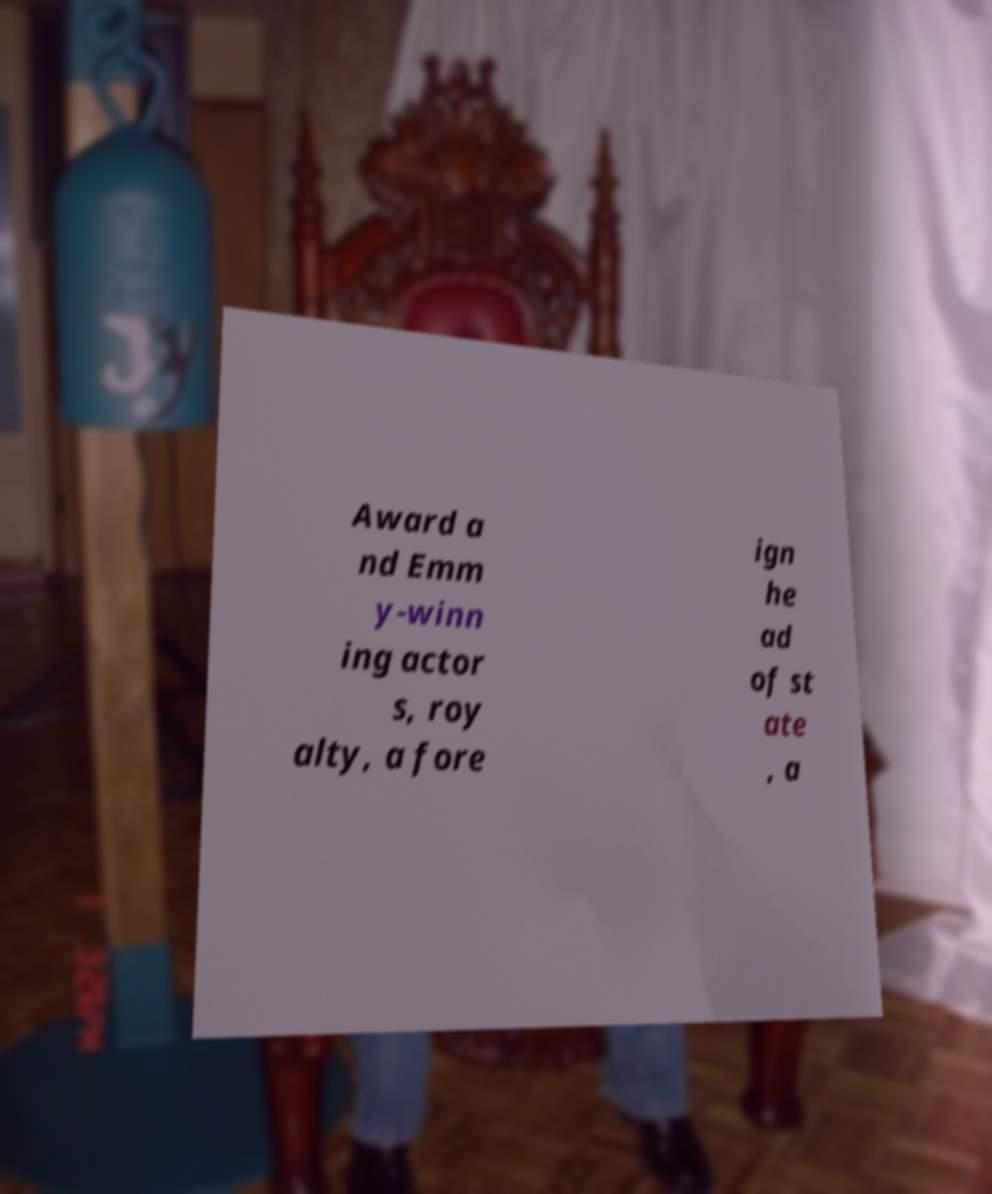For documentation purposes, I need the text within this image transcribed. Could you provide that? Award a nd Emm y-winn ing actor s, roy alty, a fore ign he ad of st ate , a 